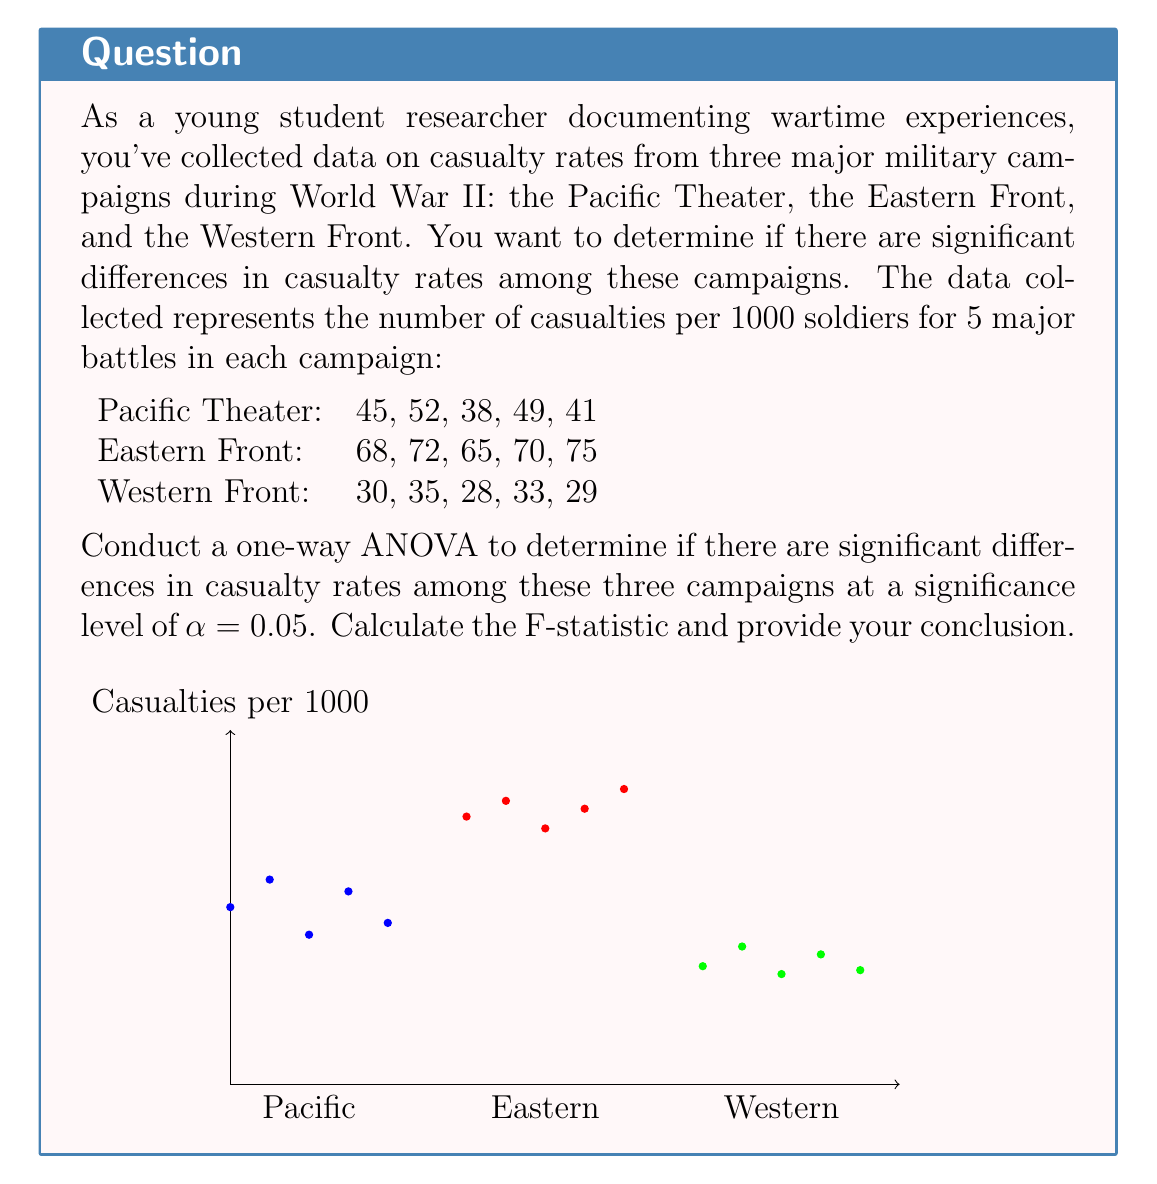Help me with this question. Let's solve this problem step by step:

1) First, we need to calculate the sum of squares:

   Within-group sum of squares (SSW):
   $$SSW = \sum_{i=1}^{k} \sum_{j=1}^{n_i} (X_{ij} - \bar{X_i})^2$$

   Between-group sum of squares (SSB):
   $$SSB = \sum_{i=1}^{k} n_i(\bar{X_i} - \bar{X})^2$$

   Where $k$ is the number of groups, $n_i$ is the number of observations in each group, $X_{ij}$ is each observation, $\bar{X_i}$ is the mean of each group, and $\bar{X}$ is the overall mean.

2) Calculate means:
   Pacific: $\bar{X_1} = 45$
   Eastern: $\bar{X_2} = 70$
   Western: $\bar{X_3} = 31$
   Overall: $\bar{X} = 48.67$

3) Calculate SSW:
   $$SSW = 252 + 82 + 52 = 386$$

4) Calculate SSB:
   $$SSB = 5(45-48.67)^2 + 5(70-48.67)^2 + 5(31-48.67)^2 = 4,830.67$$

5) Calculate degrees of freedom:
   df(between) = k - 1 = 2
   df(within) = N - k = 12
   Where N is the total number of observations (15)

6) Calculate mean squares:
   $$MSB = SSB / df(between) = 4,830.67 / 2 = 2,415.33$$
   $$MSW = SSW / df(within) = 386 / 12 = 32.17$$

7) Calculate F-statistic:
   $$F = MSB / MSW = 2,415.33 / 32.17 = 75.08$$

8) Find critical F-value:
   For α = 0.05, df(between) = 2, df(within) = 12
   F-critical = 3.89 (from F-distribution table)

9) Compare F-statistic to F-critical:
   75.08 > 3.89, so we reject the null hypothesis
Answer: F(2,12) = 75.08, p < 0.05. Significant differences exist among casualty rates. 